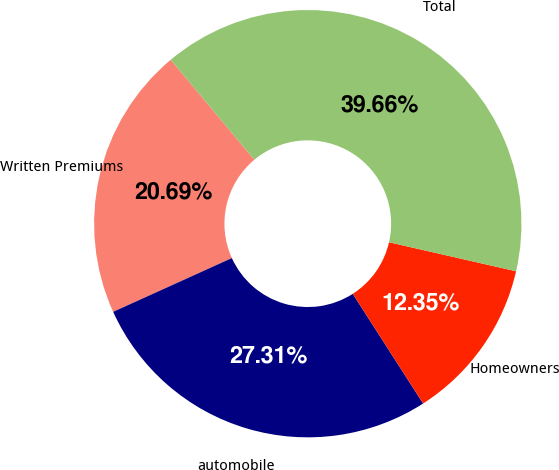Convert chart. <chart><loc_0><loc_0><loc_500><loc_500><pie_chart><fcel>Written Premiums<fcel>automobile<fcel>Homeowners<fcel>Total<nl><fcel>20.69%<fcel>27.31%<fcel>12.35%<fcel>39.66%<nl></chart> 